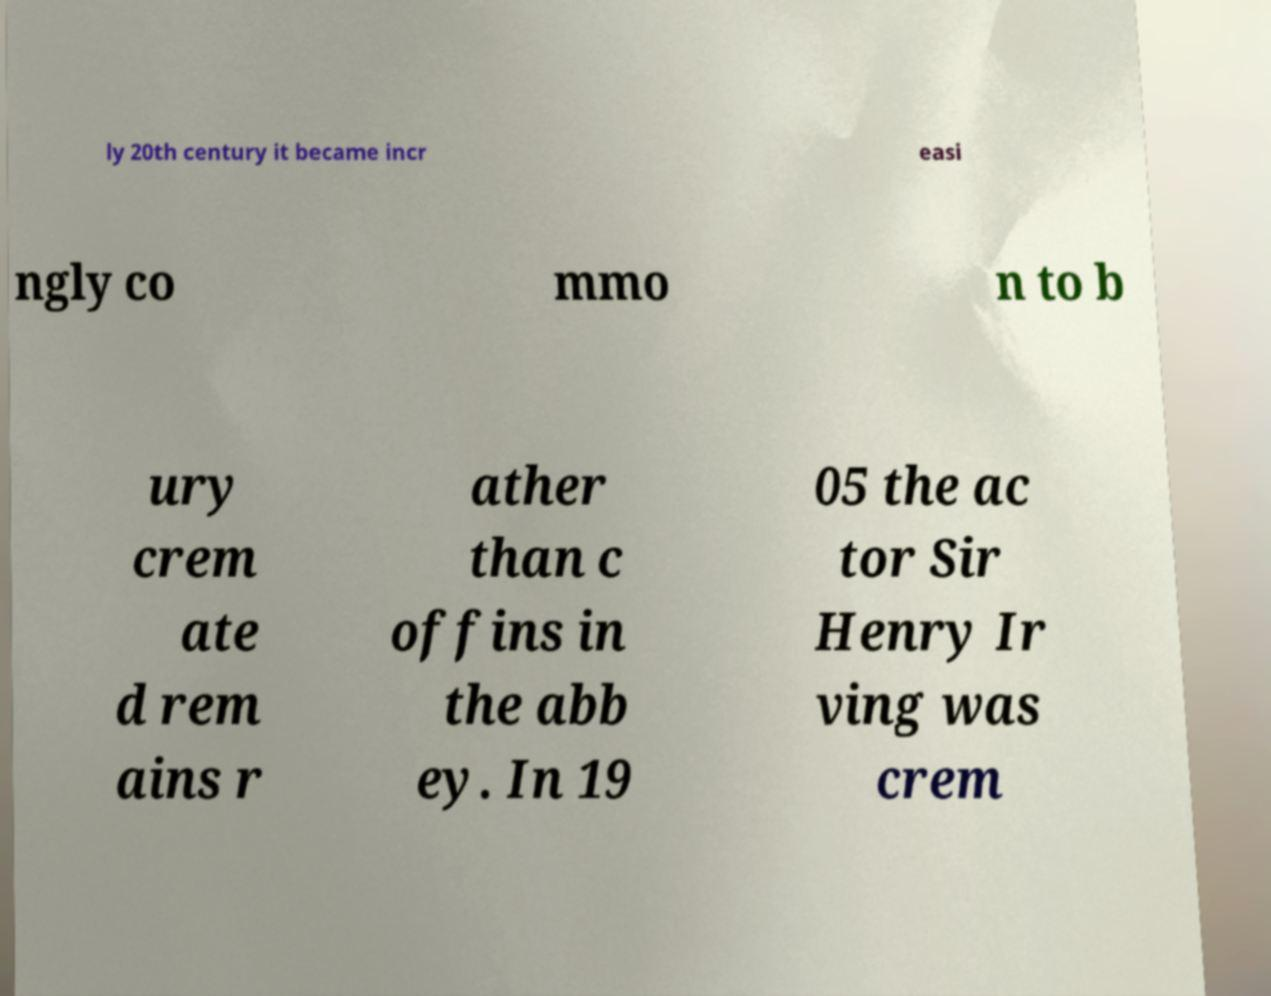Can you read and provide the text displayed in the image?This photo seems to have some interesting text. Can you extract and type it out for me? ly 20th century it became incr easi ngly co mmo n to b ury crem ate d rem ains r ather than c offins in the abb ey. In 19 05 the ac tor Sir Henry Ir ving was crem 